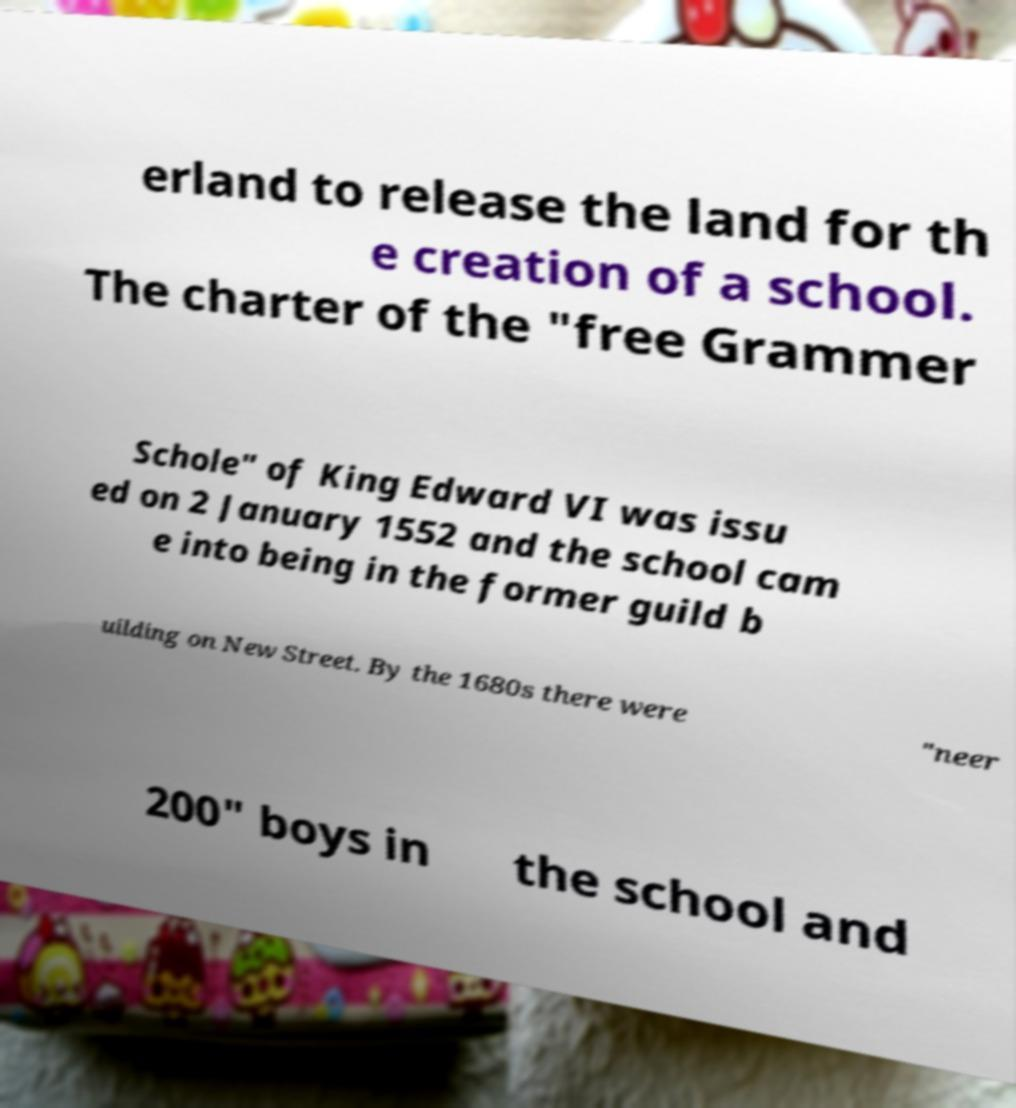For documentation purposes, I need the text within this image transcribed. Could you provide that? erland to release the land for th e creation of a school. The charter of the "free Grammer Schole" of King Edward VI was issu ed on 2 January 1552 and the school cam e into being in the former guild b uilding on New Street. By the 1680s there were "neer 200" boys in the school and 